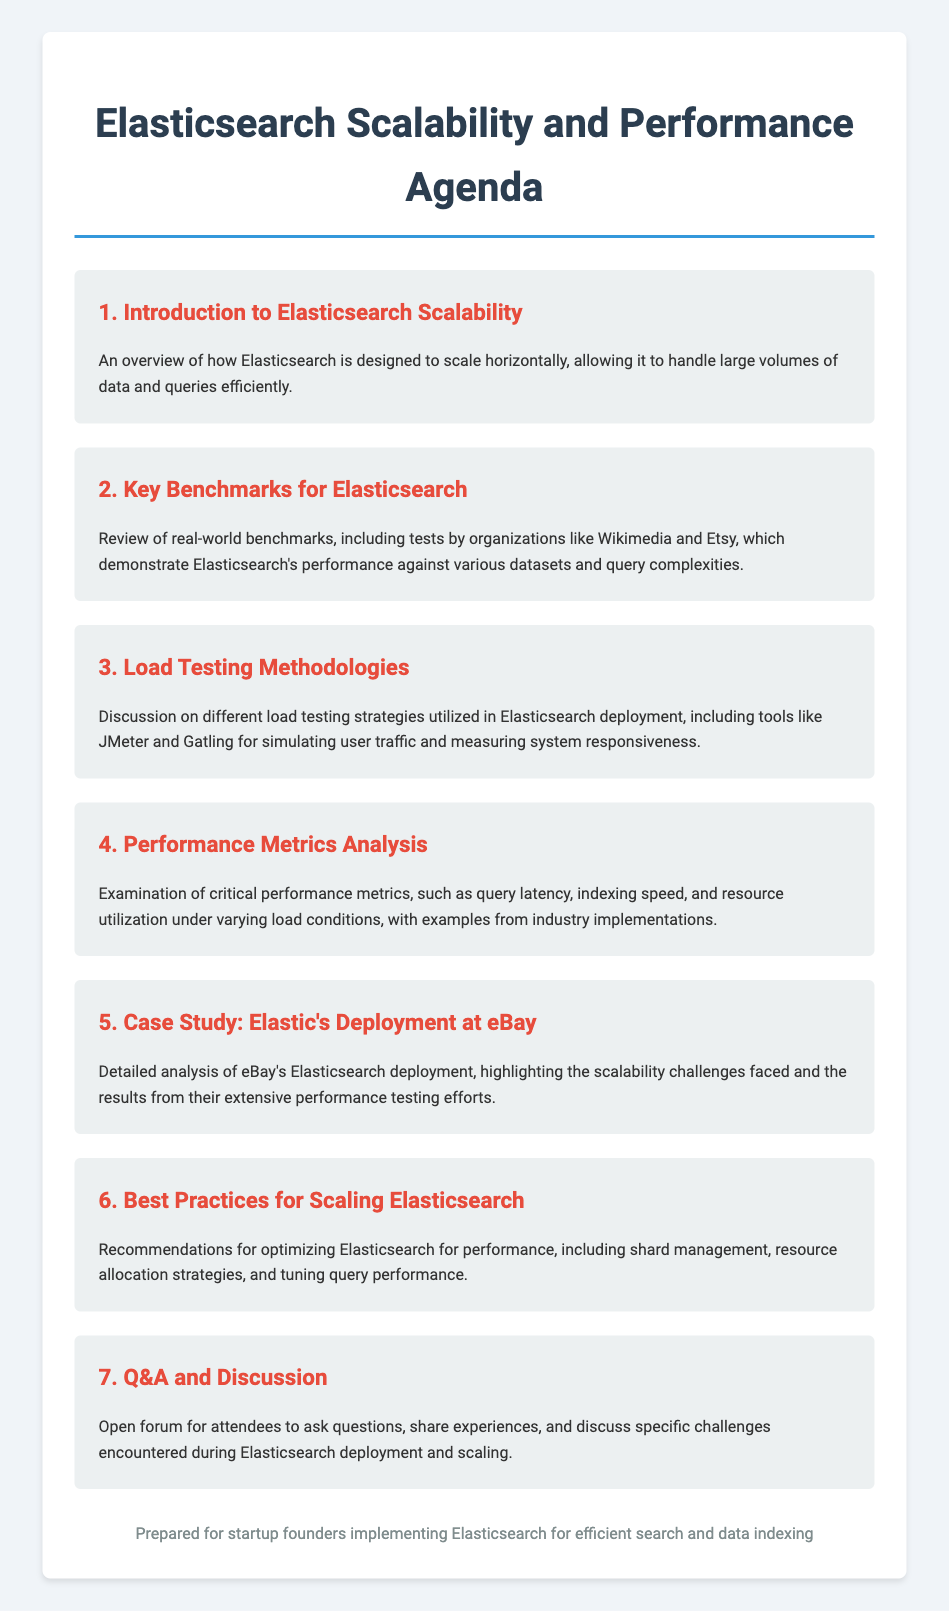What is Elasticsearch designed to do? Elasticsearch is designed to scale horizontally, allowing it to handle large volumes of data and queries efficiently.
Answer: Scale horizontally Which organizations conducted benchmarks for Elasticsearch? The document mentions real-world benchmarks conducted by organizations like Wikimedia and Etsy.
Answer: Wikimedia and Etsy What tools are mentioned for load testing in Elasticsearch? The discussion includes tools like JMeter and Gatling used for simulating user traffic and measuring system responsiveness.
Answer: JMeter and Gatling What is examined in the Performance Metrics Analysis section? This section examines critical performance metrics such as query latency, indexing speed, and resource utilization under varying load conditions.
Answer: Query latency, indexing speed, resource utilization What case study is highlighted in this agenda? The agenda features a detailed analysis of eBay's Elasticsearch deployment, focusing on scalability challenges and performance testing efforts.
Answer: eBay What is recommended for optimizing Elasticsearch for performance? Recommendations include shard management, resource allocation strategies, and tuning query performance.
Answer: Shard management, resource allocation, tuning query performance What is the format for the Q&A section? The Q&A section is described as an open forum for attendees to ask questions, share experiences, and discuss specific challenges.
Answer: Open forum 